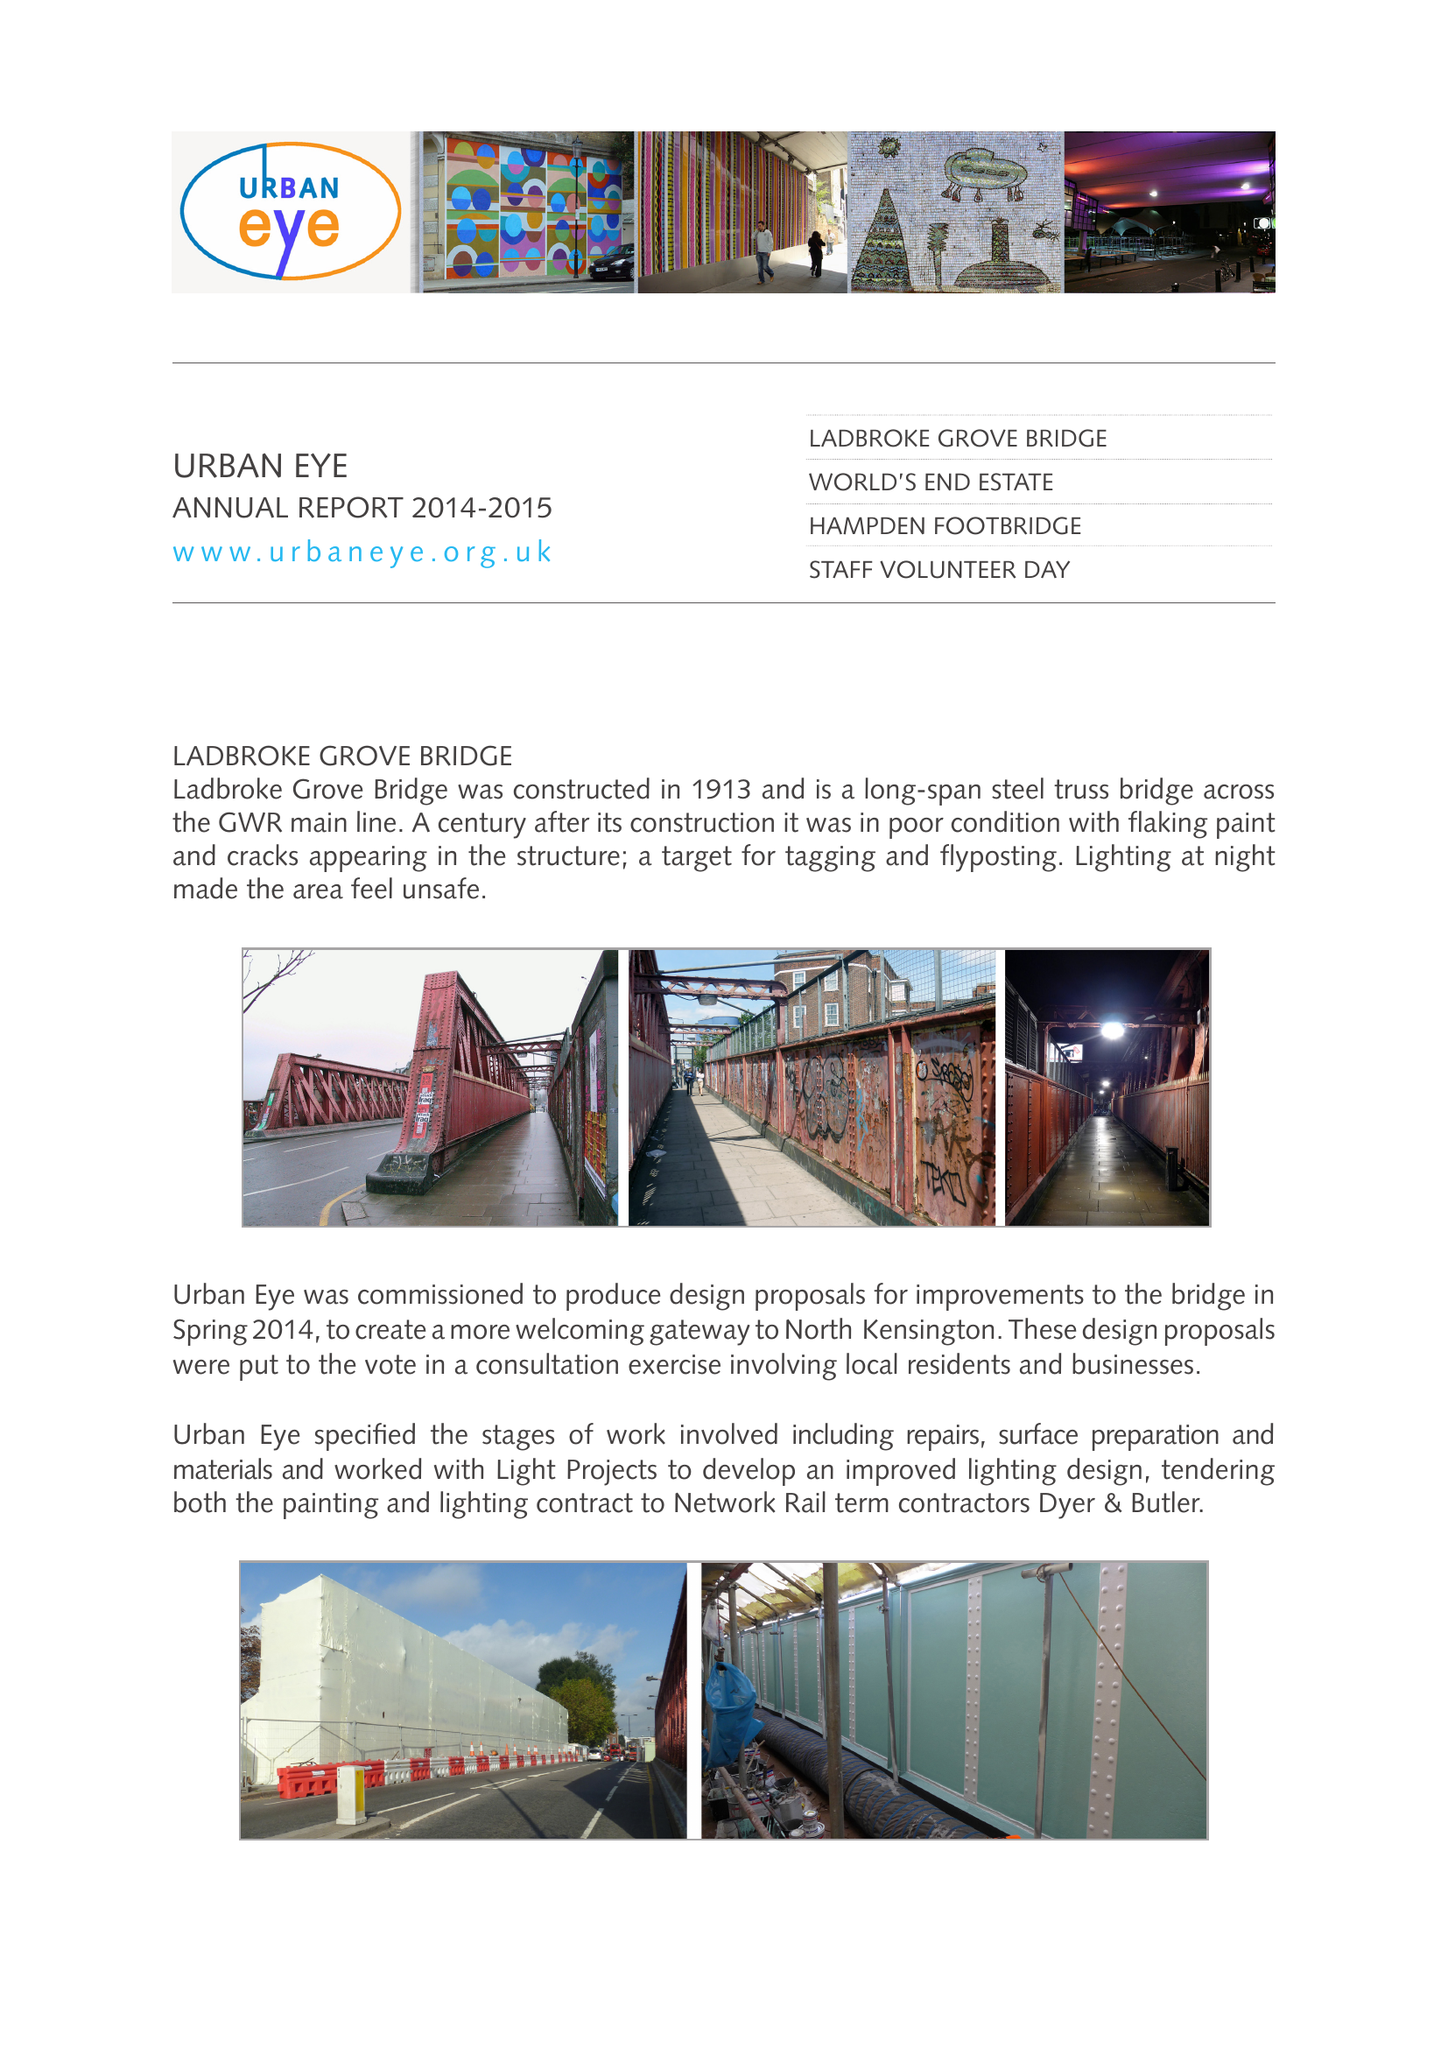What is the value for the spending_annually_in_british_pounds?
Answer the question using a single word or phrase. 55660.00 